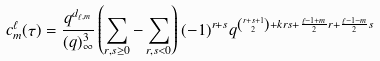<formula> <loc_0><loc_0><loc_500><loc_500>c ^ { \ell } _ { m } ( \tau ) = \frac { q ^ { d _ { \ell , m } } } { ( q ) _ { \infty } ^ { 3 } } \left ( \sum _ { r , s \geq 0 } - \sum _ { r , s < 0 } \right ) ( - 1 ) ^ { r + s } q ^ { \binom { r + s + 1 } { 2 } + k r s + \frac { \ell - 1 + m } { 2 } r + \frac { \ell - 1 - m } { 2 } s }</formula> 